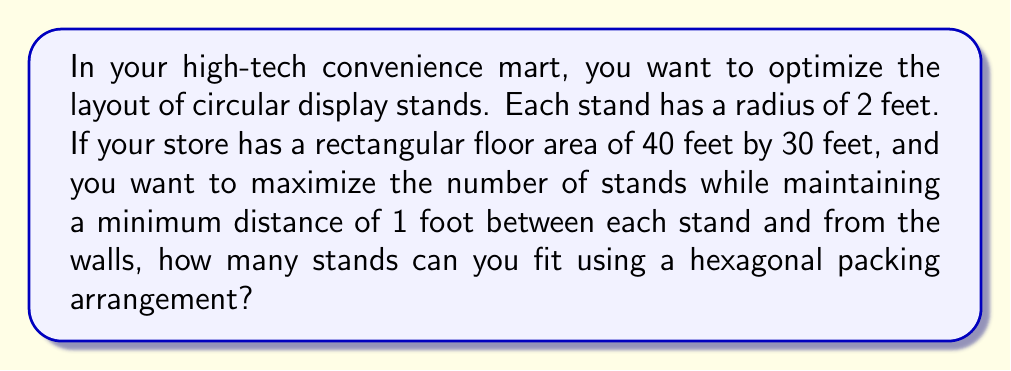Can you solve this math problem? Let's approach this step-by-step:

1) In a hexagonal packing arrangement, each circle is surrounded by 6 others. The centers of these circles form equilateral triangles.

2) The distance between the centers of two adjacent circles in this arrangement is:

   $$d = 2r + s$$

   where $r$ is the radius of each circle and $s$ is the minimum spacing.

3) In this case, $r = 2$ feet and $s = 1$ foot, so:

   $$d = 2(2) + 1 = 5\text{ feet}$$

4) The height ($h$) of an equilateral triangle with side length $d$ is:

   $$h = d \cdot \frac{\sqrt{3}}{2} = 5 \cdot \frac{\sqrt{3}}{2} = \frac{5\sqrt{3}}{2}\text{ feet}$$

5) Now, we need to determine how many rows and columns of this arrangement can fit in the store:

   Rows: $\frac{30 - 2}{h} = \frac{28}{\frac{5\sqrt{3}}{2}} \approx 6.46$
   Columns: $\frac{40 - 2}{d} = \frac{38}{5} = 7.6$

6) Rounding down, we can fit 6 rows and 7 columns.

7) In a hexagonal arrangement, alternate rows are offset. The number of circles in each row alternates between 7 and 8.

8) Total number of circles:
   $$(3 \times 8) + (3 \times 7) = 24 + 21 = 45$$

Therefore, you can fit 45 circular display stands in your store using this arrangement.
Answer: 45 stands 